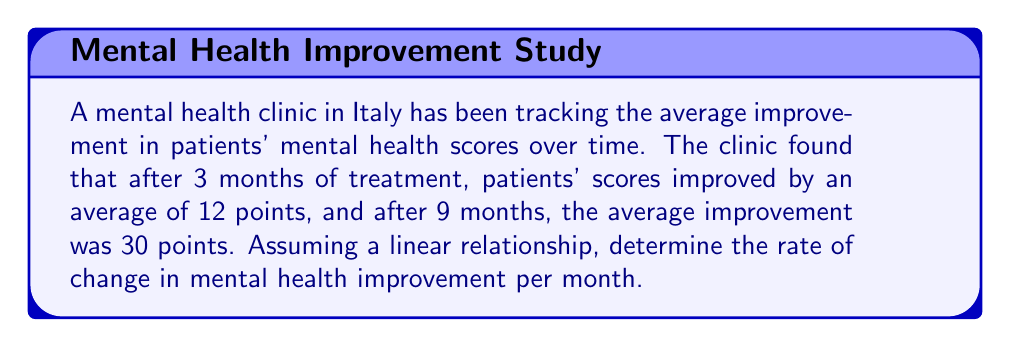Show me your answer to this math problem. To solve this problem, we'll use the rate of change formula:

$$\text{Rate of Change} = \frac{\text{Change in y}}{\text{Change in x}}$$

Let's define our variables:
- x: time in months
- y: mental health score improvement

We have two points:
1. After 3 months: (3, 12)
2. After 9 months: (9, 30)

Now, let's plug these into our formula:

$$\text{Rate of Change} = \frac{y_2 - y_1}{x_2 - x_1} = \frac{30 - 12}{9 - 3} = \frac{18}{6} = 3$$

This means that for each month, the mental health score improves by 3 points on average.

To verify, we can check if this rate holds for the given data:
- At 3 months: $3 \times 3 = 9$ points (close to the observed 12)
- At 9 months: $3 \times 9 = 27$ points (close to the observed 30)

The slight discrepancy is due to rounding and the assumption of perfect linearity.
Answer: 3 points per month 